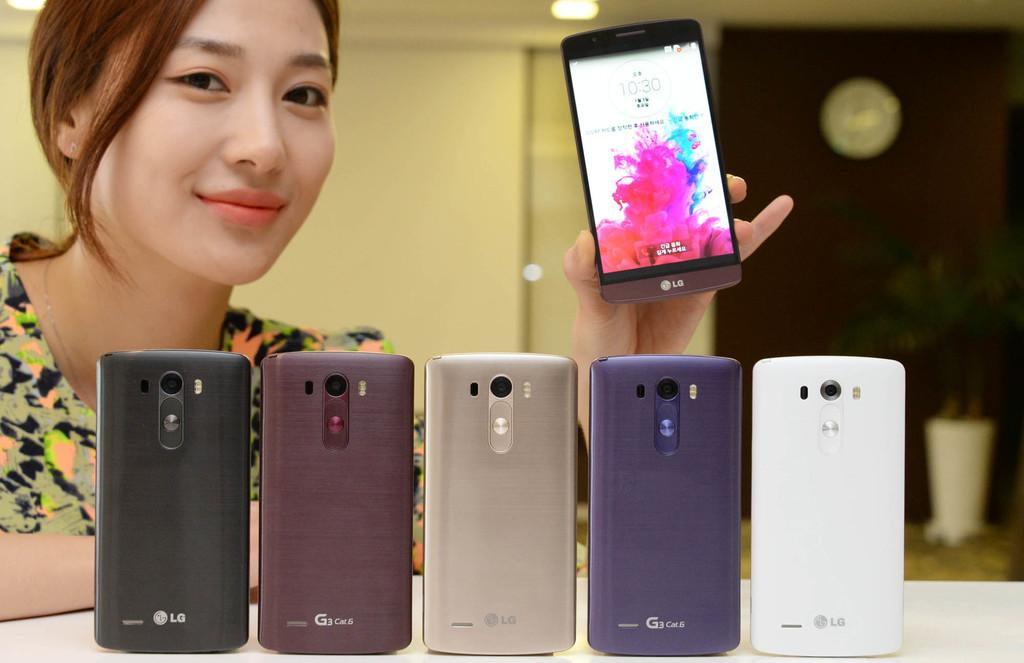Provide a one-sentence caption for the provided image. A girl holding up a phone showing the time of 10:30. 